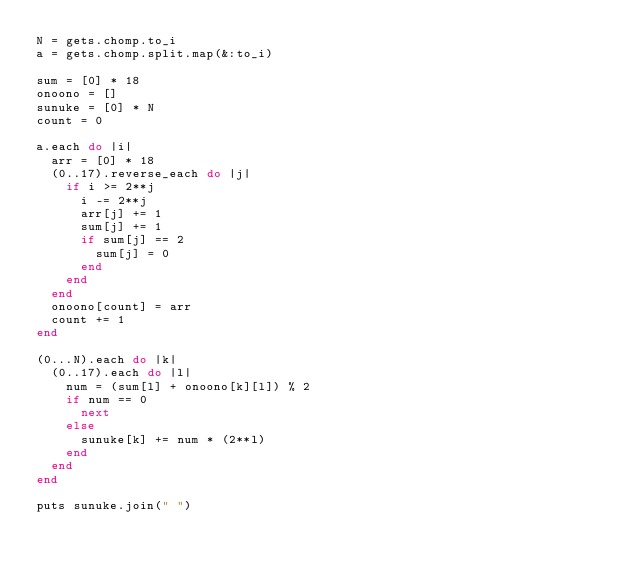Convert code to text. <code><loc_0><loc_0><loc_500><loc_500><_Ruby_>N = gets.chomp.to_i
a = gets.chomp.split.map(&:to_i)

sum = [0] * 18
onoono = []
sunuke = [0] * N
count = 0

a.each do |i|
  arr = [0] * 18
  (0..17).reverse_each do |j|
    if i >= 2**j
      i -= 2**j
      arr[j] += 1
      sum[j] += 1
      if sum[j] == 2
        sum[j] = 0
      end
    end
  end
  onoono[count] = arr
  count += 1
end

(0...N).each do |k|
  (0..17).each do |l|
    num = (sum[l] + onoono[k][l]) % 2
    if num == 0
      next
    else
      sunuke[k] += num * (2**l)
    end
  end
end

puts sunuke.join(" ")</code> 